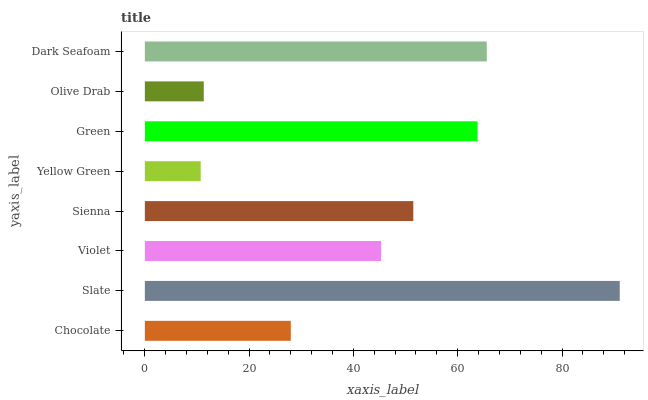Is Yellow Green the minimum?
Answer yes or no. Yes. Is Slate the maximum?
Answer yes or no. Yes. Is Violet the minimum?
Answer yes or no. No. Is Violet the maximum?
Answer yes or no. No. Is Slate greater than Violet?
Answer yes or no. Yes. Is Violet less than Slate?
Answer yes or no. Yes. Is Violet greater than Slate?
Answer yes or no. No. Is Slate less than Violet?
Answer yes or no. No. Is Sienna the high median?
Answer yes or no. Yes. Is Violet the low median?
Answer yes or no. Yes. Is Violet the high median?
Answer yes or no. No. Is Sienna the low median?
Answer yes or no. No. 